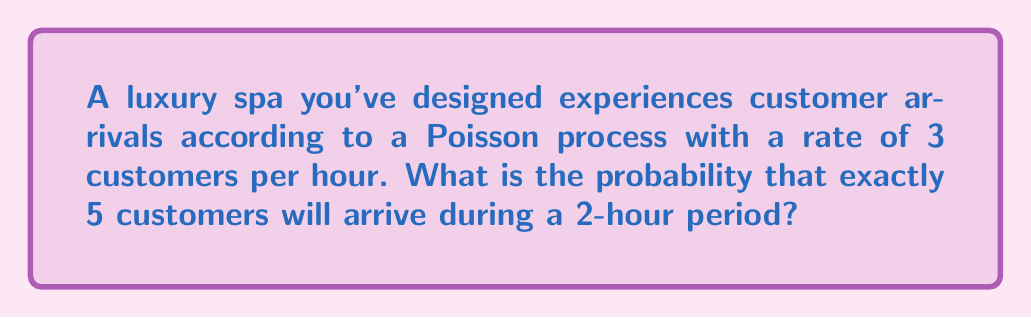Solve this math problem. To solve this problem, we'll use the Poisson distribution formula. The Poisson distribution is used to model the number of events occurring in a fixed interval of time when these events happen at a known average rate and independently of the time since the last event.

Given:
- The arrival rate (λ) is 3 customers per hour
- We're interested in a 2-hour period
- We want the probability of exactly 5 arrivals

Step 1: Calculate the average number of arrivals in 2 hours
λ_2hours = 3 customers/hour × 2 hours = 6 customers

Step 2: Use the Poisson probability mass function:
$$P(X = k) = \frac{e^{-λ} λ^k}{k!}$$

Where:
- e is Euler's number (approximately 2.71828)
- λ is the average number of events in the interval
- k is the number of events we're calculating the probability for

Step 3: Plug in the values
$$P(X = 5) = \frac{e^{-6} 6^5}{5!}$$

Step 4: Calculate
$$P(X = 5) = \frac{2.71828^{-6} \times 6^5}{5 \times 4 \times 3 \times 2 \times 1} \approx 0.1606$$

Therefore, the probability of exactly 5 customers arriving during a 2-hour period is approximately 0.1606 or 16.06%.
Answer: 0.1606 